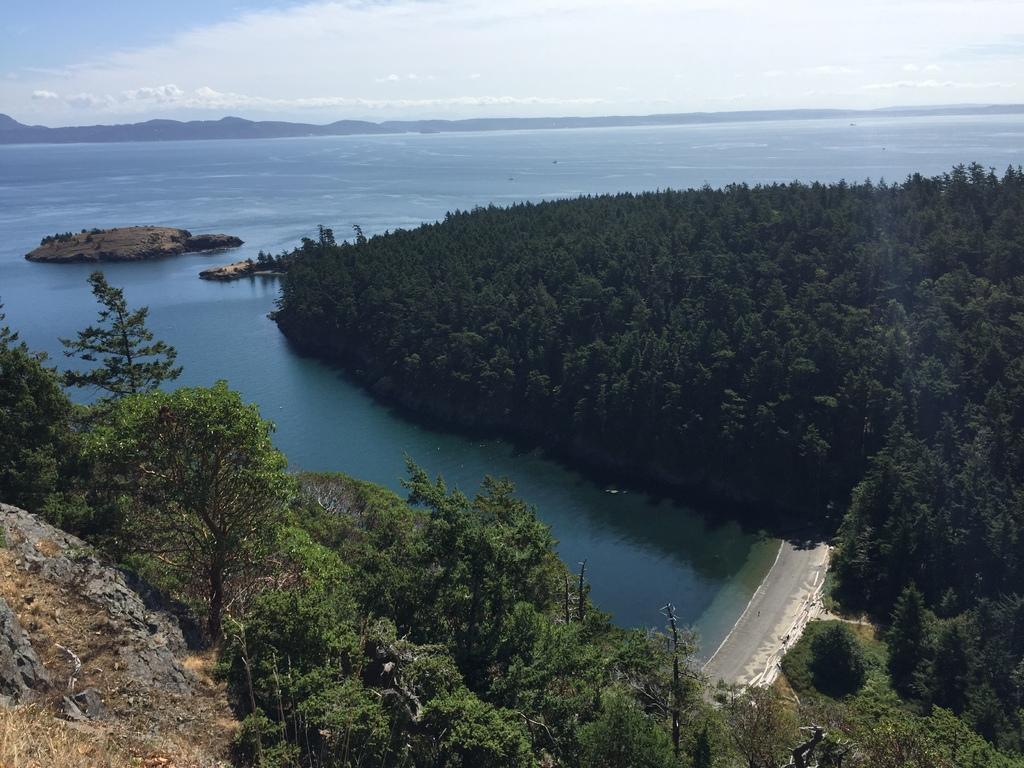Describe this image in one or two sentences. In this picture we can see trees here, at the bottom there is water, we can see the sky at the top of the picture. 